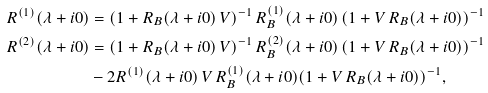Convert formula to latex. <formula><loc_0><loc_0><loc_500><loc_500>R ^ { ( 1 ) } ( \lambda + i 0 ) & = ( 1 + R _ { B } ( \lambda + i 0 ) \, V ) ^ { - 1 } \, R _ { B } ^ { ( 1 ) } ( \lambda + i 0 ) \, ( 1 + V \, R _ { B } ( \lambda + i 0 ) ) ^ { - 1 } \\ R ^ { ( 2 ) } ( \lambda + i 0 ) & = ( 1 + R _ { B } ( \lambda + i 0 ) \, V ) ^ { - 1 } \, R _ { B } ^ { ( 2 ) } ( \lambda + i 0 ) \, ( 1 + V \, R _ { B } ( \lambda + i 0 ) ) ^ { - 1 } \\ & - 2 R ^ { ( 1 ) } ( \lambda + i 0 ) \, V \, R _ { B } ^ { ( 1 ) } ( \lambda + i 0 ) ( 1 + V \, R _ { B } ( \lambda + i 0 ) ) ^ { - 1 } ,</formula> 